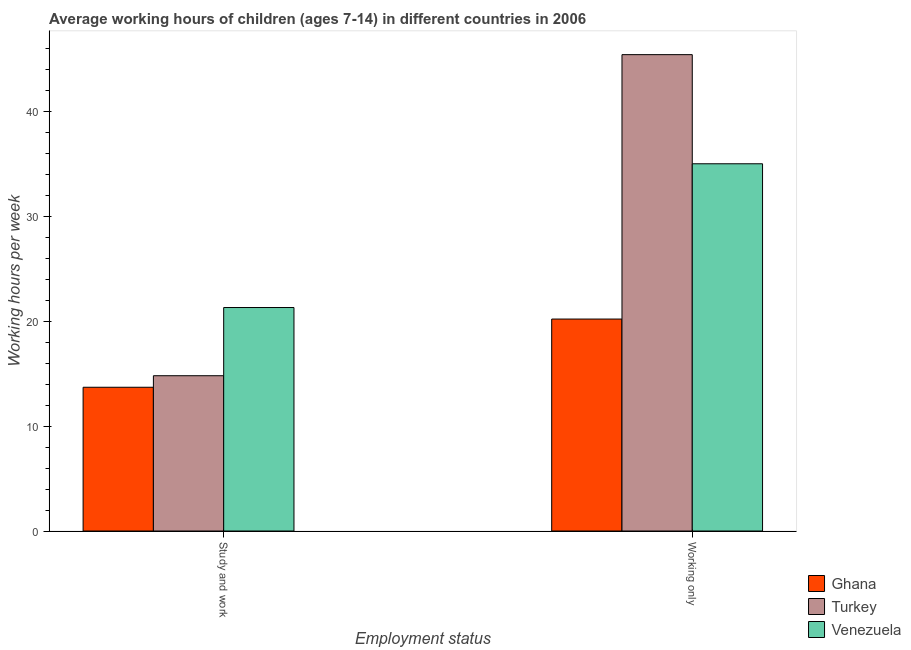How many different coloured bars are there?
Your response must be concise. 3. How many groups of bars are there?
Offer a terse response. 2. Are the number of bars per tick equal to the number of legend labels?
Keep it short and to the point. Yes. How many bars are there on the 1st tick from the left?
Provide a short and direct response. 3. What is the label of the 1st group of bars from the left?
Your answer should be compact. Study and work. What is the average working hour of children involved in only work in Turkey?
Offer a very short reply. 45.4. Across all countries, what is the maximum average working hour of children involved in study and work?
Offer a very short reply. 21.3. Across all countries, what is the minimum average working hour of children involved in only work?
Offer a terse response. 20.2. In which country was the average working hour of children involved in study and work maximum?
Offer a terse response. Venezuela. What is the total average working hour of children involved in only work in the graph?
Your answer should be compact. 100.6. What is the difference between the average working hour of children involved in study and work in Turkey and that in Ghana?
Give a very brief answer. 1.1. What is the difference between the average working hour of children involved in only work in Turkey and the average working hour of children involved in study and work in Ghana?
Offer a very short reply. 31.7. What is the average average working hour of children involved in study and work per country?
Your answer should be compact. 16.6. What is the ratio of the average working hour of children involved in only work in Venezuela to that in Turkey?
Offer a very short reply. 0.77. What does the 1st bar from the right in Study and work represents?
Provide a short and direct response. Venezuela. Are all the bars in the graph horizontal?
Your answer should be very brief. No. How many countries are there in the graph?
Your response must be concise. 3. Does the graph contain any zero values?
Give a very brief answer. No. Does the graph contain grids?
Provide a succinct answer. No. Where does the legend appear in the graph?
Give a very brief answer. Bottom right. How many legend labels are there?
Your answer should be very brief. 3. How are the legend labels stacked?
Give a very brief answer. Vertical. What is the title of the graph?
Your answer should be compact. Average working hours of children (ages 7-14) in different countries in 2006. What is the label or title of the X-axis?
Offer a very short reply. Employment status. What is the label or title of the Y-axis?
Ensure brevity in your answer.  Working hours per week. What is the Working hours per week of Ghana in Study and work?
Offer a very short reply. 13.7. What is the Working hours per week in Turkey in Study and work?
Provide a succinct answer. 14.8. What is the Working hours per week of Venezuela in Study and work?
Give a very brief answer. 21.3. What is the Working hours per week of Ghana in Working only?
Keep it short and to the point. 20.2. What is the Working hours per week in Turkey in Working only?
Offer a very short reply. 45.4. What is the Working hours per week in Venezuela in Working only?
Your answer should be compact. 35. Across all Employment status, what is the maximum Working hours per week of Ghana?
Offer a very short reply. 20.2. Across all Employment status, what is the maximum Working hours per week of Turkey?
Your answer should be very brief. 45.4. Across all Employment status, what is the maximum Working hours per week of Venezuela?
Your answer should be compact. 35. Across all Employment status, what is the minimum Working hours per week in Turkey?
Make the answer very short. 14.8. Across all Employment status, what is the minimum Working hours per week in Venezuela?
Make the answer very short. 21.3. What is the total Working hours per week in Ghana in the graph?
Offer a terse response. 33.9. What is the total Working hours per week in Turkey in the graph?
Give a very brief answer. 60.2. What is the total Working hours per week of Venezuela in the graph?
Give a very brief answer. 56.3. What is the difference between the Working hours per week of Ghana in Study and work and that in Working only?
Ensure brevity in your answer.  -6.5. What is the difference between the Working hours per week in Turkey in Study and work and that in Working only?
Provide a short and direct response. -30.6. What is the difference between the Working hours per week of Venezuela in Study and work and that in Working only?
Ensure brevity in your answer.  -13.7. What is the difference between the Working hours per week of Ghana in Study and work and the Working hours per week of Turkey in Working only?
Make the answer very short. -31.7. What is the difference between the Working hours per week of Ghana in Study and work and the Working hours per week of Venezuela in Working only?
Your answer should be compact. -21.3. What is the difference between the Working hours per week in Turkey in Study and work and the Working hours per week in Venezuela in Working only?
Your response must be concise. -20.2. What is the average Working hours per week in Ghana per Employment status?
Give a very brief answer. 16.95. What is the average Working hours per week of Turkey per Employment status?
Your answer should be very brief. 30.1. What is the average Working hours per week in Venezuela per Employment status?
Make the answer very short. 28.15. What is the difference between the Working hours per week in Ghana and Working hours per week in Turkey in Study and work?
Ensure brevity in your answer.  -1.1. What is the difference between the Working hours per week in Ghana and Working hours per week in Venezuela in Study and work?
Give a very brief answer. -7.6. What is the difference between the Working hours per week in Turkey and Working hours per week in Venezuela in Study and work?
Keep it short and to the point. -6.5. What is the difference between the Working hours per week in Ghana and Working hours per week in Turkey in Working only?
Provide a succinct answer. -25.2. What is the difference between the Working hours per week in Ghana and Working hours per week in Venezuela in Working only?
Keep it short and to the point. -14.8. What is the ratio of the Working hours per week of Ghana in Study and work to that in Working only?
Your answer should be compact. 0.68. What is the ratio of the Working hours per week of Turkey in Study and work to that in Working only?
Your answer should be compact. 0.33. What is the ratio of the Working hours per week of Venezuela in Study and work to that in Working only?
Give a very brief answer. 0.61. What is the difference between the highest and the second highest Working hours per week of Ghana?
Provide a succinct answer. 6.5. What is the difference between the highest and the second highest Working hours per week in Turkey?
Your answer should be compact. 30.6. What is the difference between the highest and the second highest Working hours per week in Venezuela?
Make the answer very short. 13.7. What is the difference between the highest and the lowest Working hours per week of Ghana?
Keep it short and to the point. 6.5. What is the difference between the highest and the lowest Working hours per week in Turkey?
Offer a very short reply. 30.6. What is the difference between the highest and the lowest Working hours per week in Venezuela?
Keep it short and to the point. 13.7. 